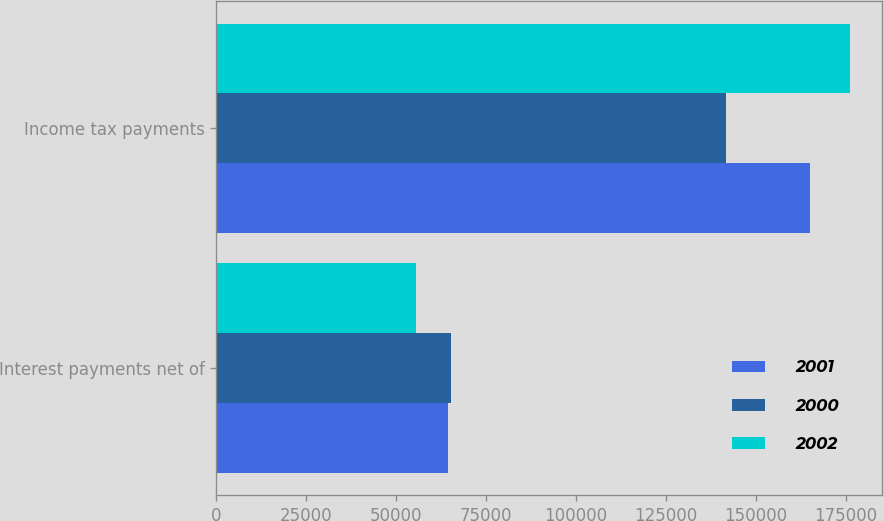Convert chart. <chart><loc_0><loc_0><loc_500><loc_500><stacked_bar_chart><ecel><fcel>Interest payments net of<fcel>Income tax payments<nl><fcel>2001<fcel>64541<fcel>165118<nl><fcel>2000<fcel>65225<fcel>141661<nl><fcel>2002<fcel>55384<fcel>176235<nl></chart> 